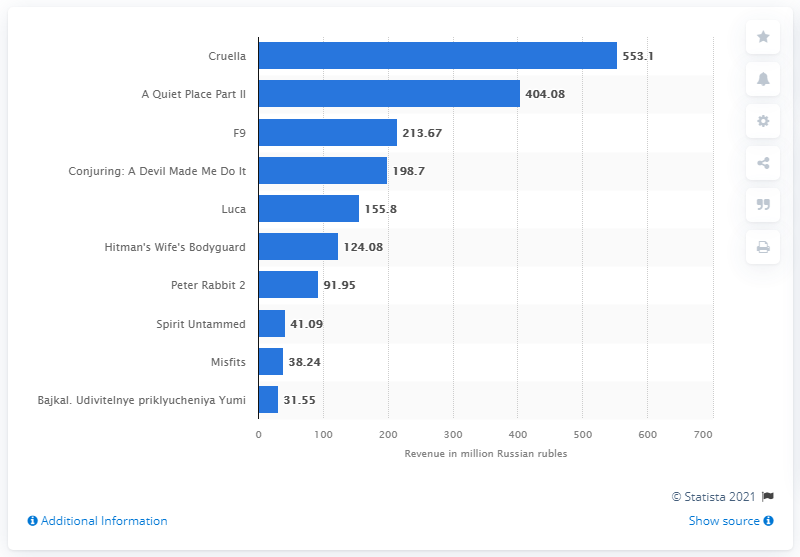Outline some significant characteristics in this image. The box office earnings of "A Quiet Place Part II" were 404.08. The gross box office in Russia in June 2021 was 553.1 million dollars. 